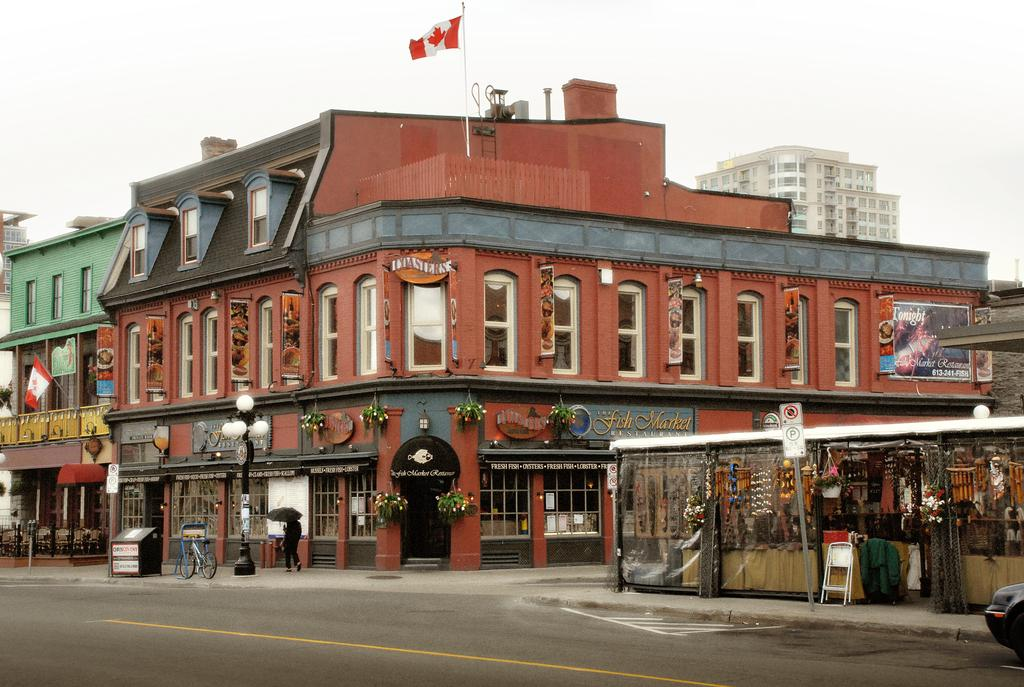What type of pathway is visible in the image? There is a road in the image. What mode of transportation can be seen on the road? There is a car in the image. What is the surface next to the road used for? There is a sidewalk in the image, which is typically used for pedestrians. What is the person on the sidewalk doing? There is a person standing on the sidewalk. What are the boards in the image used for? The purpose of the boards in the image is not specified, but they could be used for construction or signage. What are the poles in the image used for? The poles in the image could be used for various purposes, such as streetlights, traffic signals, or signage. What type of vegetation is present in the image? There are plants in the image. What type of structures are visible in the image? There are buildings in the image. What is visible in the background of the image? The sky is visible in the background of the image. How many geese are flying over the buildings in the image? There are no geese visible in the image; it only features a road, a car, a sidewalk, a person, boards, poles, plants, buildings, and the sky. What type of print can be seen on the car's license plate in the image? There is no information about the car's license plate in the provided facts, so we cannot determine the type of print on it. 